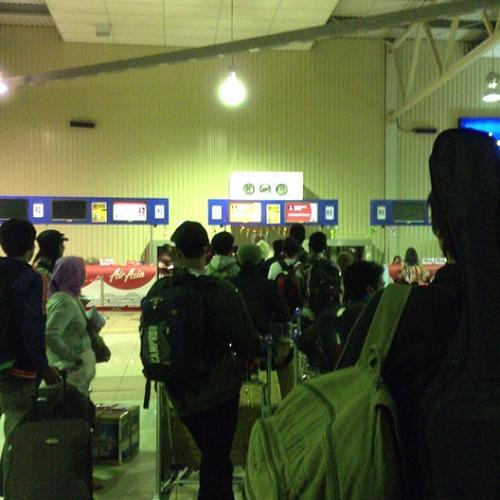Describe the appearance of the man's hat. The man is wearing a black hat, which is likely a cap. What kind of backpack is the person holding? The person is holding a light-colored backpack. Describe the appearance and location of the light in the image. There is a round light under supporting beams and ceiling panel, likely hanging from a single wire. Explain where the boxes are located in the image. Boxes are on the floor, but the specific location within the room is unclear. What are the people doing at the airport in the image? People are waiting in line at the airport, possibly for tickets or to board an airplane. What is the color and pattern of the floor in the image? The floor is covered in yellow and tan tiles. Count the number of people waiting in line in the image. There is a large group of people waiting in line, but the exact number cannot be determined from the given information. Mention the type of luggage one of the persons is holding. The man is holding a wheeled suitcase. What is written on the red and white sign? The sign reads "Air Asia." Identify the color and type of cloth worn on the woman's head. The woman has a purple cloth, possibly a scarf or headscarf, over her head. 